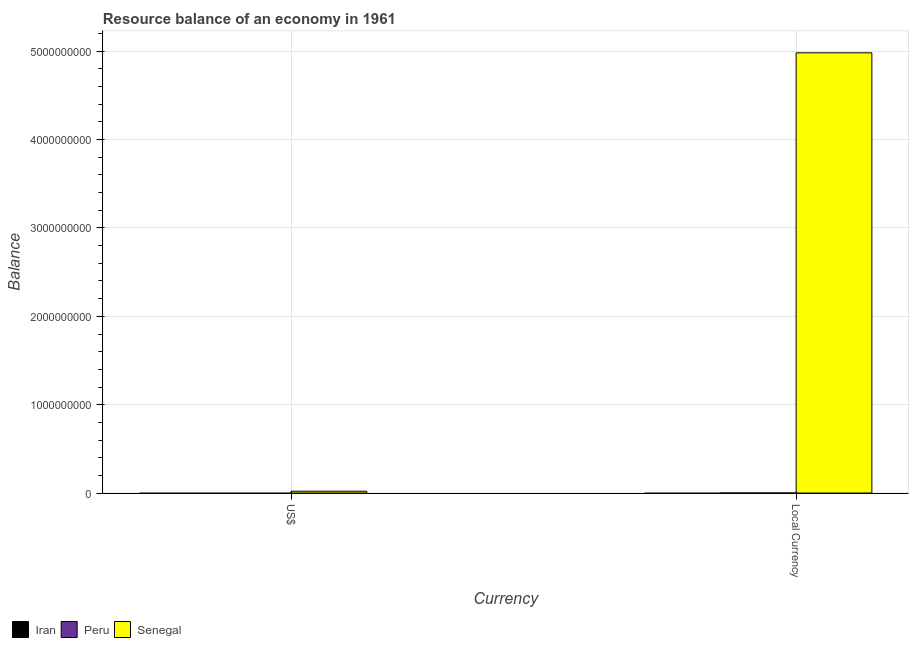How many different coloured bars are there?
Provide a succinct answer. 1. Are the number of bars per tick equal to the number of legend labels?
Keep it short and to the point. No. Are the number of bars on each tick of the X-axis equal?
Provide a short and direct response. Yes. How many bars are there on the 1st tick from the left?
Your answer should be compact. 1. How many bars are there on the 2nd tick from the right?
Your response must be concise. 1. What is the label of the 1st group of bars from the left?
Make the answer very short. US$. What is the resource balance in constant us$ in Senegal?
Offer a terse response. 4.98e+09. Across all countries, what is the maximum resource balance in constant us$?
Provide a short and direct response. 4.98e+09. In which country was the resource balance in us$ maximum?
Give a very brief answer. Senegal. What is the total resource balance in us$ in the graph?
Keep it short and to the point. 2.03e+07. What is the difference between the resource balance in constant us$ in Senegal and the resource balance in us$ in Iran?
Keep it short and to the point. 4.98e+09. What is the average resource balance in us$ per country?
Ensure brevity in your answer.  6.77e+06. What is the difference between the resource balance in constant us$ and resource balance in us$ in Senegal?
Your answer should be very brief. 4.96e+09. How many countries are there in the graph?
Provide a succinct answer. 3. Does the graph contain grids?
Offer a very short reply. Yes. Where does the legend appear in the graph?
Offer a very short reply. Bottom left. How many legend labels are there?
Your response must be concise. 3. What is the title of the graph?
Offer a very short reply. Resource balance of an economy in 1961. Does "Madagascar" appear as one of the legend labels in the graph?
Make the answer very short. No. What is the label or title of the X-axis?
Ensure brevity in your answer.  Currency. What is the label or title of the Y-axis?
Offer a terse response. Balance. What is the Balance in Peru in US$?
Give a very brief answer. 0. What is the Balance of Senegal in US$?
Offer a very short reply. 2.03e+07. What is the Balance of Iran in Local Currency?
Provide a short and direct response. 0. What is the Balance in Peru in Local Currency?
Your response must be concise. 0. What is the Balance in Senegal in Local Currency?
Your answer should be very brief. 4.98e+09. Across all Currency, what is the maximum Balance of Senegal?
Make the answer very short. 4.98e+09. Across all Currency, what is the minimum Balance in Senegal?
Keep it short and to the point. 2.03e+07. What is the total Balance of Senegal in the graph?
Your answer should be very brief. 5.00e+09. What is the difference between the Balance in Senegal in US$ and that in Local Currency?
Offer a terse response. -4.96e+09. What is the average Balance in Iran per Currency?
Make the answer very short. 0. What is the average Balance in Senegal per Currency?
Your response must be concise. 2.50e+09. What is the ratio of the Balance in Senegal in US$ to that in Local Currency?
Provide a short and direct response. 0. What is the difference between the highest and the second highest Balance in Senegal?
Give a very brief answer. 4.96e+09. What is the difference between the highest and the lowest Balance in Senegal?
Give a very brief answer. 4.96e+09. 